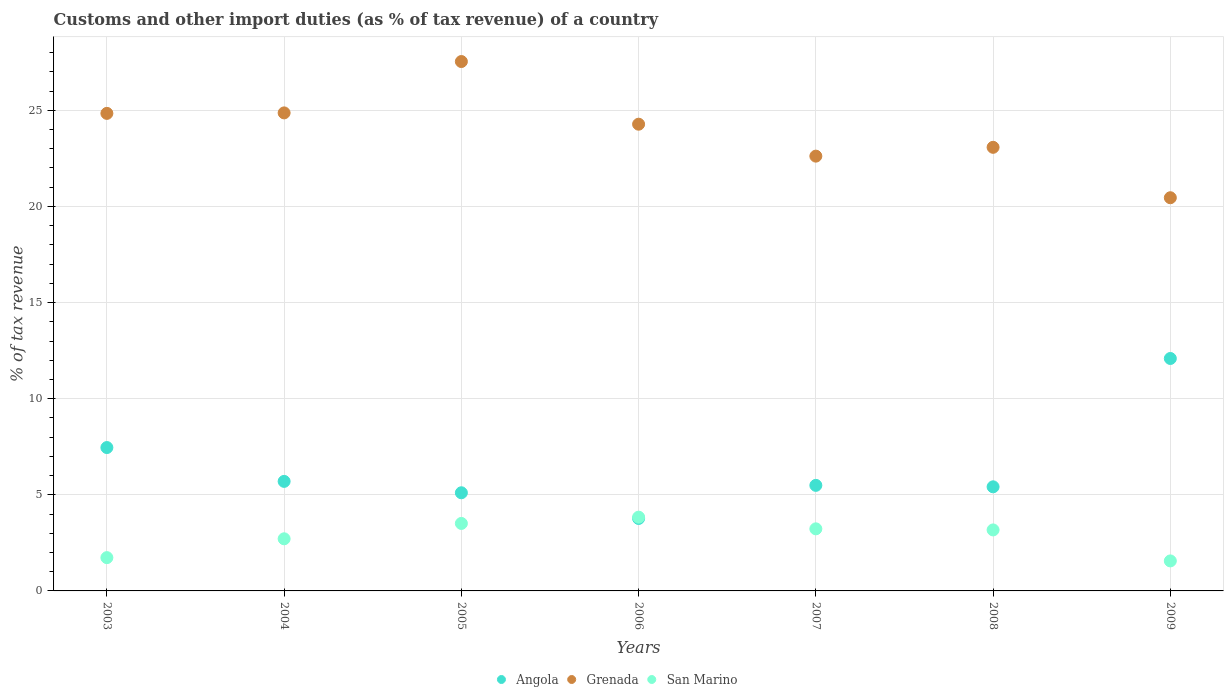How many different coloured dotlines are there?
Make the answer very short. 3. What is the percentage of tax revenue from customs in San Marino in 2009?
Offer a very short reply. 1.56. Across all years, what is the maximum percentage of tax revenue from customs in San Marino?
Your answer should be very brief. 3.84. Across all years, what is the minimum percentage of tax revenue from customs in San Marino?
Offer a very short reply. 1.56. In which year was the percentage of tax revenue from customs in Angola minimum?
Offer a very short reply. 2006. What is the total percentage of tax revenue from customs in Angola in the graph?
Your response must be concise. 45.03. What is the difference between the percentage of tax revenue from customs in Angola in 2003 and that in 2005?
Your answer should be very brief. 2.35. What is the difference between the percentage of tax revenue from customs in San Marino in 2005 and the percentage of tax revenue from customs in Grenada in 2009?
Your answer should be compact. -16.94. What is the average percentage of tax revenue from customs in Grenada per year?
Make the answer very short. 23.95. In the year 2008, what is the difference between the percentage of tax revenue from customs in San Marino and percentage of tax revenue from customs in Angola?
Make the answer very short. -2.24. In how many years, is the percentage of tax revenue from customs in San Marino greater than 16 %?
Provide a short and direct response. 0. What is the ratio of the percentage of tax revenue from customs in San Marino in 2007 to that in 2008?
Keep it short and to the point. 1.02. What is the difference between the highest and the second highest percentage of tax revenue from customs in Grenada?
Your answer should be very brief. 2.67. What is the difference between the highest and the lowest percentage of tax revenue from customs in Grenada?
Ensure brevity in your answer.  7.08. In how many years, is the percentage of tax revenue from customs in Angola greater than the average percentage of tax revenue from customs in Angola taken over all years?
Your response must be concise. 2. Is the sum of the percentage of tax revenue from customs in Angola in 2003 and 2005 greater than the maximum percentage of tax revenue from customs in San Marino across all years?
Ensure brevity in your answer.  Yes. Is it the case that in every year, the sum of the percentage of tax revenue from customs in San Marino and percentage of tax revenue from customs in Angola  is greater than the percentage of tax revenue from customs in Grenada?
Ensure brevity in your answer.  No. Is the percentage of tax revenue from customs in Grenada strictly greater than the percentage of tax revenue from customs in Angola over the years?
Provide a short and direct response. Yes. Is the percentage of tax revenue from customs in Angola strictly less than the percentage of tax revenue from customs in Grenada over the years?
Your answer should be compact. Yes. How many years are there in the graph?
Your answer should be compact. 7. Are the values on the major ticks of Y-axis written in scientific E-notation?
Give a very brief answer. No. Does the graph contain grids?
Ensure brevity in your answer.  Yes. What is the title of the graph?
Give a very brief answer. Customs and other import duties (as % of tax revenue) of a country. What is the label or title of the X-axis?
Offer a terse response. Years. What is the label or title of the Y-axis?
Your answer should be very brief. % of tax revenue. What is the % of tax revenue in Angola in 2003?
Your answer should be very brief. 7.46. What is the % of tax revenue in Grenada in 2003?
Keep it short and to the point. 24.84. What is the % of tax revenue in San Marino in 2003?
Keep it short and to the point. 1.73. What is the % of tax revenue of Angola in 2004?
Provide a succinct answer. 5.7. What is the % of tax revenue of Grenada in 2004?
Keep it short and to the point. 24.87. What is the % of tax revenue in San Marino in 2004?
Keep it short and to the point. 2.71. What is the % of tax revenue in Angola in 2005?
Your answer should be very brief. 5.11. What is the % of tax revenue in Grenada in 2005?
Make the answer very short. 27.54. What is the % of tax revenue of San Marino in 2005?
Make the answer very short. 3.51. What is the % of tax revenue of Angola in 2006?
Offer a very short reply. 3.77. What is the % of tax revenue of Grenada in 2006?
Offer a terse response. 24.28. What is the % of tax revenue of San Marino in 2006?
Keep it short and to the point. 3.84. What is the % of tax revenue of Angola in 2007?
Ensure brevity in your answer.  5.49. What is the % of tax revenue in Grenada in 2007?
Offer a very short reply. 22.62. What is the % of tax revenue in San Marino in 2007?
Keep it short and to the point. 3.23. What is the % of tax revenue of Angola in 2008?
Keep it short and to the point. 5.42. What is the % of tax revenue in Grenada in 2008?
Your answer should be compact. 23.08. What is the % of tax revenue of San Marino in 2008?
Your response must be concise. 3.17. What is the % of tax revenue of Angola in 2009?
Your answer should be compact. 12.09. What is the % of tax revenue in Grenada in 2009?
Offer a very short reply. 20.45. What is the % of tax revenue of San Marino in 2009?
Keep it short and to the point. 1.56. Across all years, what is the maximum % of tax revenue of Angola?
Give a very brief answer. 12.09. Across all years, what is the maximum % of tax revenue in Grenada?
Make the answer very short. 27.54. Across all years, what is the maximum % of tax revenue in San Marino?
Offer a terse response. 3.84. Across all years, what is the minimum % of tax revenue of Angola?
Give a very brief answer. 3.77. Across all years, what is the minimum % of tax revenue in Grenada?
Provide a succinct answer. 20.45. Across all years, what is the minimum % of tax revenue in San Marino?
Your answer should be compact. 1.56. What is the total % of tax revenue in Angola in the graph?
Make the answer very short. 45.03. What is the total % of tax revenue of Grenada in the graph?
Your answer should be compact. 167.67. What is the total % of tax revenue of San Marino in the graph?
Your answer should be very brief. 19.75. What is the difference between the % of tax revenue of Angola in 2003 and that in 2004?
Your answer should be very brief. 1.76. What is the difference between the % of tax revenue of Grenada in 2003 and that in 2004?
Your answer should be very brief. -0.03. What is the difference between the % of tax revenue in San Marino in 2003 and that in 2004?
Your response must be concise. -0.98. What is the difference between the % of tax revenue of Angola in 2003 and that in 2005?
Ensure brevity in your answer.  2.35. What is the difference between the % of tax revenue of Grenada in 2003 and that in 2005?
Your answer should be compact. -2.7. What is the difference between the % of tax revenue in San Marino in 2003 and that in 2005?
Your answer should be compact. -1.78. What is the difference between the % of tax revenue of Angola in 2003 and that in 2006?
Make the answer very short. 3.69. What is the difference between the % of tax revenue in Grenada in 2003 and that in 2006?
Provide a short and direct response. 0.56. What is the difference between the % of tax revenue of San Marino in 2003 and that in 2006?
Ensure brevity in your answer.  -2.11. What is the difference between the % of tax revenue of Angola in 2003 and that in 2007?
Your response must be concise. 1.97. What is the difference between the % of tax revenue of Grenada in 2003 and that in 2007?
Keep it short and to the point. 2.22. What is the difference between the % of tax revenue of San Marino in 2003 and that in 2007?
Make the answer very short. -1.5. What is the difference between the % of tax revenue in Angola in 2003 and that in 2008?
Your answer should be very brief. 2.04. What is the difference between the % of tax revenue in Grenada in 2003 and that in 2008?
Your answer should be compact. 1.77. What is the difference between the % of tax revenue in San Marino in 2003 and that in 2008?
Provide a short and direct response. -1.44. What is the difference between the % of tax revenue in Angola in 2003 and that in 2009?
Ensure brevity in your answer.  -4.63. What is the difference between the % of tax revenue in Grenada in 2003 and that in 2009?
Give a very brief answer. 4.39. What is the difference between the % of tax revenue of San Marino in 2003 and that in 2009?
Give a very brief answer. 0.17. What is the difference between the % of tax revenue in Angola in 2004 and that in 2005?
Your answer should be very brief. 0.59. What is the difference between the % of tax revenue of Grenada in 2004 and that in 2005?
Your answer should be very brief. -2.67. What is the difference between the % of tax revenue of San Marino in 2004 and that in 2005?
Your answer should be compact. -0.8. What is the difference between the % of tax revenue in Angola in 2004 and that in 2006?
Offer a very short reply. 1.93. What is the difference between the % of tax revenue of Grenada in 2004 and that in 2006?
Your response must be concise. 0.59. What is the difference between the % of tax revenue of San Marino in 2004 and that in 2006?
Your answer should be very brief. -1.13. What is the difference between the % of tax revenue in Angola in 2004 and that in 2007?
Ensure brevity in your answer.  0.21. What is the difference between the % of tax revenue in Grenada in 2004 and that in 2007?
Your answer should be compact. 2.25. What is the difference between the % of tax revenue of San Marino in 2004 and that in 2007?
Offer a very short reply. -0.52. What is the difference between the % of tax revenue of Angola in 2004 and that in 2008?
Give a very brief answer. 0.28. What is the difference between the % of tax revenue of Grenada in 2004 and that in 2008?
Make the answer very short. 1.79. What is the difference between the % of tax revenue of San Marino in 2004 and that in 2008?
Provide a short and direct response. -0.46. What is the difference between the % of tax revenue in Angola in 2004 and that in 2009?
Offer a very short reply. -6.39. What is the difference between the % of tax revenue in Grenada in 2004 and that in 2009?
Make the answer very short. 4.41. What is the difference between the % of tax revenue of San Marino in 2004 and that in 2009?
Ensure brevity in your answer.  1.15. What is the difference between the % of tax revenue in Angola in 2005 and that in 2006?
Offer a terse response. 1.34. What is the difference between the % of tax revenue in Grenada in 2005 and that in 2006?
Offer a terse response. 3.26. What is the difference between the % of tax revenue in San Marino in 2005 and that in 2006?
Offer a very short reply. -0.33. What is the difference between the % of tax revenue of Angola in 2005 and that in 2007?
Provide a short and direct response. -0.39. What is the difference between the % of tax revenue in Grenada in 2005 and that in 2007?
Offer a terse response. 4.92. What is the difference between the % of tax revenue in San Marino in 2005 and that in 2007?
Provide a succinct answer. 0.28. What is the difference between the % of tax revenue of Angola in 2005 and that in 2008?
Ensure brevity in your answer.  -0.31. What is the difference between the % of tax revenue in Grenada in 2005 and that in 2008?
Offer a terse response. 4.46. What is the difference between the % of tax revenue in San Marino in 2005 and that in 2008?
Give a very brief answer. 0.34. What is the difference between the % of tax revenue of Angola in 2005 and that in 2009?
Make the answer very short. -6.99. What is the difference between the % of tax revenue in Grenada in 2005 and that in 2009?
Offer a terse response. 7.08. What is the difference between the % of tax revenue in San Marino in 2005 and that in 2009?
Offer a very short reply. 1.95. What is the difference between the % of tax revenue of Angola in 2006 and that in 2007?
Offer a terse response. -1.72. What is the difference between the % of tax revenue of Grenada in 2006 and that in 2007?
Your answer should be compact. 1.66. What is the difference between the % of tax revenue in San Marino in 2006 and that in 2007?
Provide a succinct answer. 0.61. What is the difference between the % of tax revenue in Angola in 2006 and that in 2008?
Offer a terse response. -1.65. What is the difference between the % of tax revenue of Grenada in 2006 and that in 2008?
Your response must be concise. 1.2. What is the difference between the % of tax revenue of San Marino in 2006 and that in 2008?
Your answer should be compact. 0.66. What is the difference between the % of tax revenue in Angola in 2006 and that in 2009?
Provide a succinct answer. -8.32. What is the difference between the % of tax revenue of Grenada in 2006 and that in 2009?
Provide a succinct answer. 3.83. What is the difference between the % of tax revenue of San Marino in 2006 and that in 2009?
Your answer should be compact. 2.28. What is the difference between the % of tax revenue in Angola in 2007 and that in 2008?
Make the answer very short. 0.08. What is the difference between the % of tax revenue in Grenada in 2007 and that in 2008?
Offer a very short reply. -0.46. What is the difference between the % of tax revenue of San Marino in 2007 and that in 2008?
Your answer should be compact. 0.06. What is the difference between the % of tax revenue of Angola in 2007 and that in 2009?
Your answer should be compact. -6.6. What is the difference between the % of tax revenue of Grenada in 2007 and that in 2009?
Provide a short and direct response. 2.16. What is the difference between the % of tax revenue in San Marino in 2007 and that in 2009?
Your answer should be very brief. 1.67. What is the difference between the % of tax revenue in Angola in 2008 and that in 2009?
Provide a succinct answer. -6.68. What is the difference between the % of tax revenue of Grenada in 2008 and that in 2009?
Offer a very short reply. 2.62. What is the difference between the % of tax revenue of San Marino in 2008 and that in 2009?
Make the answer very short. 1.61. What is the difference between the % of tax revenue in Angola in 2003 and the % of tax revenue in Grenada in 2004?
Your response must be concise. -17.41. What is the difference between the % of tax revenue of Angola in 2003 and the % of tax revenue of San Marino in 2004?
Give a very brief answer. 4.75. What is the difference between the % of tax revenue in Grenada in 2003 and the % of tax revenue in San Marino in 2004?
Offer a very short reply. 22.13. What is the difference between the % of tax revenue of Angola in 2003 and the % of tax revenue of Grenada in 2005?
Ensure brevity in your answer.  -20.08. What is the difference between the % of tax revenue in Angola in 2003 and the % of tax revenue in San Marino in 2005?
Your response must be concise. 3.95. What is the difference between the % of tax revenue of Grenada in 2003 and the % of tax revenue of San Marino in 2005?
Provide a short and direct response. 21.33. What is the difference between the % of tax revenue of Angola in 2003 and the % of tax revenue of Grenada in 2006?
Ensure brevity in your answer.  -16.82. What is the difference between the % of tax revenue in Angola in 2003 and the % of tax revenue in San Marino in 2006?
Ensure brevity in your answer.  3.62. What is the difference between the % of tax revenue of Grenada in 2003 and the % of tax revenue of San Marino in 2006?
Offer a terse response. 21. What is the difference between the % of tax revenue of Angola in 2003 and the % of tax revenue of Grenada in 2007?
Offer a very short reply. -15.16. What is the difference between the % of tax revenue in Angola in 2003 and the % of tax revenue in San Marino in 2007?
Provide a succinct answer. 4.23. What is the difference between the % of tax revenue of Grenada in 2003 and the % of tax revenue of San Marino in 2007?
Provide a short and direct response. 21.61. What is the difference between the % of tax revenue of Angola in 2003 and the % of tax revenue of Grenada in 2008?
Your answer should be compact. -15.62. What is the difference between the % of tax revenue in Angola in 2003 and the % of tax revenue in San Marino in 2008?
Your answer should be compact. 4.29. What is the difference between the % of tax revenue of Grenada in 2003 and the % of tax revenue of San Marino in 2008?
Give a very brief answer. 21.67. What is the difference between the % of tax revenue in Angola in 2003 and the % of tax revenue in Grenada in 2009?
Ensure brevity in your answer.  -12.99. What is the difference between the % of tax revenue of Angola in 2003 and the % of tax revenue of San Marino in 2009?
Your answer should be compact. 5.9. What is the difference between the % of tax revenue of Grenada in 2003 and the % of tax revenue of San Marino in 2009?
Your answer should be very brief. 23.28. What is the difference between the % of tax revenue of Angola in 2004 and the % of tax revenue of Grenada in 2005?
Make the answer very short. -21.84. What is the difference between the % of tax revenue of Angola in 2004 and the % of tax revenue of San Marino in 2005?
Keep it short and to the point. 2.19. What is the difference between the % of tax revenue of Grenada in 2004 and the % of tax revenue of San Marino in 2005?
Make the answer very short. 21.36. What is the difference between the % of tax revenue of Angola in 2004 and the % of tax revenue of Grenada in 2006?
Make the answer very short. -18.58. What is the difference between the % of tax revenue in Angola in 2004 and the % of tax revenue in San Marino in 2006?
Offer a very short reply. 1.86. What is the difference between the % of tax revenue of Grenada in 2004 and the % of tax revenue of San Marino in 2006?
Your answer should be very brief. 21.03. What is the difference between the % of tax revenue in Angola in 2004 and the % of tax revenue in Grenada in 2007?
Ensure brevity in your answer.  -16.92. What is the difference between the % of tax revenue in Angola in 2004 and the % of tax revenue in San Marino in 2007?
Your answer should be very brief. 2.47. What is the difference between the % of tax revenue in Grenada in 2004 and the % of tax revenue in San Marino in 2007?
Your answer should be very brief. 21.64. What is the difference between the % of tax revenue in Angola in 2004 and the % of tax revenue in Grenada in 2008?
Make the answer very short. -17.38. What is the difference between the % of tax revenue in Angola in 2004 and the % of tax revenue in San Marino in 2008?
Offer a very short reply. 2.52. What is the difference between the % of tax revenue of Grenada in 2004 and the % of tax revenue of San Marino in 2008?
Offer a terse response. 21.69. What is the difference between the % of tax revenue in Angola in 2004 and the % of tax revenue in Grenada in 2009?
Make the answer very short. -14.76. What is the difference between the % of tax revenue in Angola in 2004 and the % of tax revenue in San Marino in 2009?
Give a very brief answer. 4.14. What is the difference between the % of tax revenue in Grenada in 2004 and the % of tax revenue in San Marino in 2009?
Provide a short and direct response. 23.31. What is the difference between the % of tax revenue of Angola in 2005 and the % of tax revenue of Grenada in 2006?
Ensure brevity in your answer.  -19.17. What is the difference between the % of tax revenue in Angola in 2005 and the % of tax revenue in San Marino in 2006?
Offer a very short reply. 1.27. What is the difference between the % of tax revenue of Grenada in 2005 and the % of tax revenue of San Marino in 2006?
Your answer should be very brief. 23.7. What is the difference between the % of tax revenue in Angola in 2005 and the % of tax revenue in Grenada in 2007?
Provide a short and direct response. -17.51. What is the difference between the % of tax revenue of Angola in 2005 and the % of tax revenue of San Marino in 2007?
Give a very brief answer. 1.88. What is the difference between the % of tax revenue of Grenada in 2005 and the % of tax revenue of San Marino in 2007?
Offer a terse response. 24.31. What is the difference between the % of tax revenue in Angola in 2005 and the % of tax revenue in Grenada in 2008?
Offer a very short reply. -17.97. What is the difference between the % of tax revenue of Angola in 2005 and the % of tax revenue of San Marino in 2008?
Offer a very short reply. 1.93. What is the difference between the % of tax revenue of Grenada in 2005 and the % of tax revenue of San Marino in 2008?
Keep it short and to the point. 24.36. What is the difference between the % of tax revenue of Angola in 2005 and the % of tax revenue of Grenada in 2009?
Your response must be concise. -15.35. What is the difference between the % of tax revenue in Angola in 2005 and the % of tax revenue in San Marino in 2009?
Your response must be concise. 3.54. What is the difference between the % of tax revenue of Grenada in 2005 and the % of tax revenue of San Marino in 2009?
Offer a terse response. 25.98. What is the difference between the % of tax revenue of Angola in 2006 and the % of tax revenue of Grenada in 2007?
Your answer should be very brief. -18.85. What is the difference between the % of tax revenue in Angola in 2006 and the % of tax revenue in San Marino in 2007?
Make the answer very short. 0.54. What is the difference between the % of tax revenue of Grenada in 2006 and the % of tax revenue of San Marino in 2007?
Make the answer very short. 21.05. What is the difference between the % of tax revenue in Angola in 2006 and the % of tax revenue in Grenada in 2008?
Give a very brief answer. -19.31. What is the difference between the % of tax revenue of Angola in 2006 and the % of tax revenue of San Marino in 2008?
Provide a succinct answer. 0.6. What is the difference between the % of tax revenue in Grenada in 2006 and the % of tax revenue in San Marino in 2008?
Your answer should be compact. 21.11. What is the difference between the % of tax revenue of Angola in 2006 and the % of tax revenue of Grenada in 2009?
Your response must be concise. -16.68. What is the difference between the % of tax revenue in Angola in 2006 and the % of tax revenue in San Marino in 2009?
Make the answer very short. 2.21. What is the difference between the % of tax revenue of Grenada in 2006 and the % of tax revenue of San Marino in 2009?
Provide a short and direct response. 22.72. What is the difference between the % of tax revenue in Angola in 2007 and the % of tax revenue in Grenada in 2008?
Ensure brevity in your answer.  -17.58. What is the difference between the % of tax revenue in Angola in 2007 and the % of tax revenue in San Marino in 2008?
Keep it short and to the point. 2.32. What is the difference between the % of tax revenue in Grenada in 2007 and the % of tax revenue in San Marino in 2008?
Your answer should be compact. 19.44. What is the difference between the % of tax revenue in Angola in 2007 and the % of tax revenue in Grenada in 2009?
Provide a short and direct response. -14.96. What is the difference between the % of tax revenue in Angola in 2007 and the % of tax revenue in San Marino in 2009?
Your response must be concise. 3.93. What is the difference between the % of tax revenue in Grenada in 2007 and the % of tax revenue in San Marino in 2009?
Offer a terse response. 21.06. What is the difference between the % of tax revenue in Angola in 2008 and the % of tax revenue in Grenada in 2009?
Offer a very short reply. -15.04. What is the difference between the % of tax revenue in Angola in 2008 and the % of tax revenue in San Marino in 2009?
Keep it short and to the point. 3.85. What is the difference between the % of tax revenue of Grenada in 2008 and the % of tax revenue of San Marino in 2009?
Ensure brevity in your answer.  21.51. What is the average % of tax revenue in Angola per year?
Offer a terse response. 6.43. What is the average % of tax revenue of Grenada per year?
Your answer should be compact. 23.95. What is the average % of tax revenue of San Marino per year?
Keep it short and to the point. 2.82. In the year 2003, what is the difference between the % of tax revenue of Angola and % of tax revenue of Grenada?
Ensure brevity in your answer.  -17.38. In the year 2003, what is the difference between the % of tax revenue in Angola and % of tax revenue in San Marino?
Your response must be concise. 5.73. In the year 2003, what is the difference between the % of tax revenue of Grenada and % of tax revenue of San Marino?
Offer a very short reply. 23.11. In the year 2004, what is the difference between the % of tax revenue in Angola and % of tax revenue in Grenada?
Give a very brief answer. -19.17. In the year 2004, what is the difference between the % of tax revenue of Angola and % of tax revenue of San Marino?
Your response must be concise. 2.99. In the year 2004, what is the difference between the % of tax revenue of Grenada and % of tax revenue of San Marino?
Make the answer very short. 22.15. In the year 2005, what is the difference between the % of tax revenue of Angola and % of tax revenue of Grenada?
Provide a succinct answer. -22.43. In the year 2005, what is the difference between the % of tax revenue in Angola and % of tax revenue in San Marino?
Keep it short and to the point. 1.59. In the year 2005, what is the difference between the % of tax revenue in Grenada and % of tax revenue in San Marino?
Offer a terse response. 24.03. In the year 2006, what is the difference between the % of tax revenue in Angola and % of tax revenue in Grenada?
Offer a terse response. -20.51. In the year 2006, what is the difference between the % of tax revenue in Angola and % of tax revenue in San Marino?
Your answer should be very brief. -0.07. In the year 2006, what is the difference between the % of tax revenue of Grenada and % of tax revenue of San Marino?
Your answer should be very brief. 20.44. In the year 2007, what is the difference between the % of tax revenue of Angola and % of tax revenue of Grenada?
Your answer should be very brief. -17.13. In the year 2007, what is the difference between the % of tax revenue in Angola and % of tax revenue in San Marino?
Your response must be concise. 2.26. In the year 2007, what is the difference between the % of tax revenue in Grenada and % of tax revenue in San Marino?
Your answer should be very brief. 19.39. In the year 2008, what is the difference between the % of tax revenue of Angola and % of tax revenue of Grenada?
Your answer should be compact. -17.66. In the year 2008, what is the difference between the % of tax revenue of Angola and % of tax revenue of San Marino?
Your response must be concise. 2.24. In the year 2008, what is the difference between the % of tax revenue in Grenada and % of tax revenue in San Marino?
Your answer should be compact. 19.9. In the year 2009, what is the difference between the % of tax revenue in Angola and % of tax revenue in Grenada?
Provide a short and direct response. -8.36. In the year 2009, what is the difference between the % of tax revenue in Angola and % of tax revenue in San Marino?
Give a very brief answer. 10.53. In the year 2009, what is the difference between the % of tax revenue of Grenada and % of tax revenue of San Marino?
Give a very brief answer. 18.89. What is the ratio of the % of tax revenue in Angola in 2003 to that in 2004?
Make the answer very short. 1.31. What is the ratio of the % of tax revenue in Grenada in 2003 to that in 2004?
Offer a terse response. 1. What is the ratio of the % of tax revenue of San Marino in 2003 to that in 2004?
Provide a short and direct response. 0.64. What is the ratio of the % of tax revenue in Angola in 2003 to that in 2005?
Provide a short and direct response. 1.46. What is the ratio of the % of tax revenue in Grenada in 2003 to that in 2005?
Give a very brief answer. 0.9. What is the ratio of the % of tax revenue of San Marino in 2003 to that in 2005?
Give a very brief answer. 0.49. What is the ratio of the % of tax revenue in Angola in 2003 to that in 2006?
Your answer should be compact. 1.98. What is the ratio of the % of tax revenue in Grenada in 2003 to that in 2006?
Offer a very short reply. 1.02. What is the ratio of the % of tax revenue in San Marino in 2003 to that in 2006?
Offer a terse response. 0.45. What is the ratio of the % of tax revenue in Angola in 2003 to that in 2007?
Your answer should be very brief. 1.36. What is the ratio of the % of tax revenue in Grenada in 2003 to that in 2007?
Ensure brevity in your answer.  1.1. What is the ratio of the % of tax revenue in San Marino in 2003 to that in 2007?
Ensure brevity in your answer.  0.54. What is the ratio of the % of tax revenue in Angola in 2003 to that in 2008?
Your answer should be very brief. 1.38. What is the ratio of the % of tax revenue in Grenada in 2003 to that in 2008?
Make the answer very short. 1.08. What is the ratio of the % of tax revenue in San Marino in 2003 to that in 2008?
Ensure brevity in your answer.  0.55. What is the ratio of the % of tax revenue of Angola in 2003 to that in 2009?
Your answer should be compact. 0.62. What is the ratio of the % of tax revenue of Grenada in 2003 to that in 2009?
Your answer should be compact. 1.21. What is the ratio of the % of tax revenue in San Marino in 2003 to that in 2009?
Your answer should be compact. 1.11. What is the ratio of the % of tax revenue of Angola in 2004 to that in 2005?
Offer a very short reply. 1.12. What is the ratio of the % of tax revenue of Grenada in 2004 to that in 2005?
Make the answer very short. 0.9. What is the ratio of the % of tax revenue in San Marino in 2004 to that in 2005?
Offer a very short reply. 0.77. What is the ratio of the % of tax revenue in Angola in 2004 to that in 2006?
Keep it short and to the point. 1.51. What is the ratio of the % of tax revenue of Grenada in 2004 to that in 2006?
Provide a short and direct response. 1.02. What is the ratio of the % of tax revenue in San Marino in 2004 to that in 2006?
Make the answer very short. 0.71. What is the ratio of the % of tax revenue in Angola in 2004 to that in 2007?
Provide a succinct answer. 1.04. What is the ratio of the % of tax revenue of Grenada in 2004 to that in 2007?
Make the answer very short. 1.1. What is the ratio of the % of tax revenue of San Marino in 2004 to that in 2007?
Make the answer very short. 0.84. What is the ratio of the % of tax revenue of Angola in 2004 to that in 2008?
Give a very brief answer. 1.05. What is the ratio of the % of tax revenue of Grenada in 2004 to that in 2008?
Offer a terse response. 1.08. What is the ratio of the % of tax revenue of San Marino in 2004 to that in 2008?
Ensure brevity in your answer.  0.85. What is the ratio of the % of tax revenue of Angola in 2004 to that in 2009?
Your answer should be compact. 0.47. What is the ratio of the % of tax revenue of Grenada in 2004 to that in 2009?
Offer a terse response. 1.22. What is the ratio of the % of tax revenue of San Marino in 2004 to that in 2009?
Keep it short and to the point. 1.74. What is the ratio of the % of tax revenue in Angola in 2005 to that in 2006?
Keep it short and to the point. 1.35. What is the ratio of the % of tax revenue in Grenada in 2005 to that in 2006?
Offer a very short reply. 1.13. What is the ratio of the % of tax revenue of San Marino in 2005 to that in 2006?
Make the answer very short. 0.91. What is the ratio of the % of tax revenue in Angola in 2005 to that in 2007?
Your response must be concise. 0.93. What is the ratio of the % of tax revenue in Grenada in 2005 to that in 2007?
Give a very brief answer. 1.22. What is the ratio of the % of tax revenue of San Marino in 2005 to that in 2007?
Ensure brevity in your answer.  1.09. What is the ratio of the % of tax revenue in Angola in 2005 to that in 2008?
Your answer should be compact. 0.94. What is the ratio of the % of tax revenue of Grenada in 2005 to that in 2008?
Offer a terse response. 1.19. What is the ratio of the % of tax revenue of San Marino in 2005 to that in 2008?
Provide a succinct answer. 1.11. What is the ratio of the % of tax revenue of Angola in 2005 to that in 2009?
Your answer should be very brief. 0.42. What is the ratio of the % of tax revenue of Grenada in 2005 to that in 2009?
Provide a short and direct response. 1.35. What is the ratio of the % of tax revenue of San Marino in 2005 to that in 2009?
Your answer should be compact. 2.25. What is the ratio of the % of tax revenue in Angola in 2006 to that in 2007?
Keep it short and to the point. 0.69. What is the ratio of the % of tax revenue of Grenada in 2006 to that in 2007?
Provide a succinct answer. 1.07. What is the ratio of the % of tax revenue in San Marino in 2006 to that in 2007?
Make the answer very short. 1.19. What is the ratio of the % of tax revenue in Angola in 2006 to that in 2008?
Provide a succinct answer. 0.7. What is the ratio of the % of tax revenue of Grenada in 2006 to that in 2008?
Offer a terse response. 1.05. What is the ratio of the % of tax revenue of San Marino in 2006 to that in 2008?
Ensure brevity in your answer.  1.21. What is the ratio of the % of tax revenue of Angola in 2006 to that in 2009?
Your answer should be very brief. 0.31. What is the ratio of the % of tax revenue of Grenada in 2006 to that in 2009?
Provide a short and direct response. 1.19. What is the ratio of the % of tax revenue in San Marino in 2006 to that in 2009?
Your answer should be compact. 2.46. What is the ratio of the % of tax revenue of Angola in 2007 to that in 2008?
Ensure brevity in your answer.  1.01. What is the ratio of the % of tax revenue of Grenada in 2007 to that in 2008?
Ensure brevity in your answer.  0.98. What is the ratio of the % of tax revenue of San Marino in 2007 to that in 2008?
Provide a succinct answer. 1.02. What is the ratio of the % of tax revenue of Angola in 2007 to that in 2009?
Your answer should be very brief. 0.45. What is the ratio of the % of tax revenue in Grenada in 2007 to that in 2009?
Give a very brief answer. 1.11. What is the ratio of the % of tax revenue of San Marino in 2007 to that in 2009?
Offer a very short reply. 2.07. What is the ratio of the % of tax revenue of Angola in 2008 to that in 2009?
Keep it short and to the point. 0.45. What is the ratio of the % of tax revenue in Grenada in 2008 to that in 2009?
Provide a short and direct response. 1.13. What is the ratio of the % of tax revenue in San Marino in 2008 to that in 2009?
Make the answer very short. 2.03. What is the difference between the highest and the second highest % of tax revenue in Angola?
Provide a short and direct response. 4.63. What is the difference between the highest and the second highest % of tax revenue in Grenada?
Offer a very short reply. 2.67. What is the difference between the highest and the second highest % of tax revenue of San Marino?
Offer a very short reply. 0.33. What is the difference between the highest and the lowest % of tax revenue of Angola?
Give a very brief answer. 8.32. What is the difference between the highest and the lowest % of tax revenue in Grenada?
Provide a short and direct response. 7.08. What is the difference between the highest and the lowest % of tax revenue of San Marino?
Your answer should be compact. 2.28. 